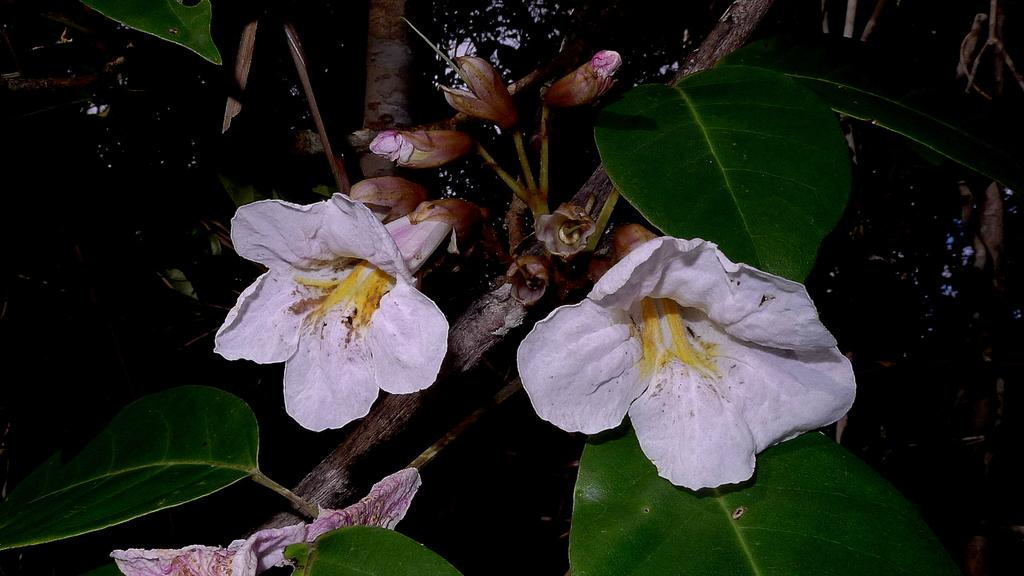What type of plant life is visible in the image? There are flowers, flower buds, branches, and leaves visible in the image. Can you describe the growth stages of the plants in the image? The image shows both flowers and flower buds, indicating different stages of growth. What else can be seen in the image besides the plants? The background of the image is dark. What type of throne is depicted in the image? There is no throne present in the image; it features plant life and a dark background. What act are the plants performing in the image? Plants do not perform acts; they are stationary and grow in the image. 